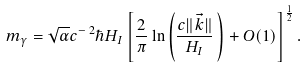Convert formula to latex. <formula><loc_0><loc_0><loc_500><loc_500>m _ { \gamma } = \sqrt { \alpha } c ^ { - \, 2 } \hbar { H } _ { I } \left [ \frac { 2 } { \pi } \ln \left ( \frac { c \| \vec { k } \| } { H _ { I } } \, \right ) + O ( 1 ) \right ] ^ { \frac { 1 } { 2 } } .</formula> 